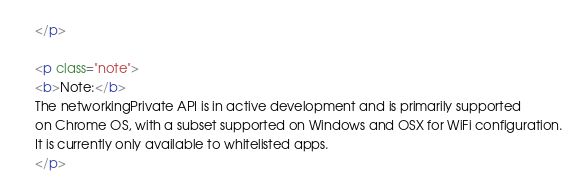<code> <loc_0><loc_0><loc_500><loc_500><_HTML_></p>

<p class="note">
<b>Note:</b>
The networkingPrivate API is in active development and is primarily supported
on Chrome OS, with a subset supported on Windows and OSX for WiFi configuration.
It is currently only available to whitelisted apps.
</p>
</code> 